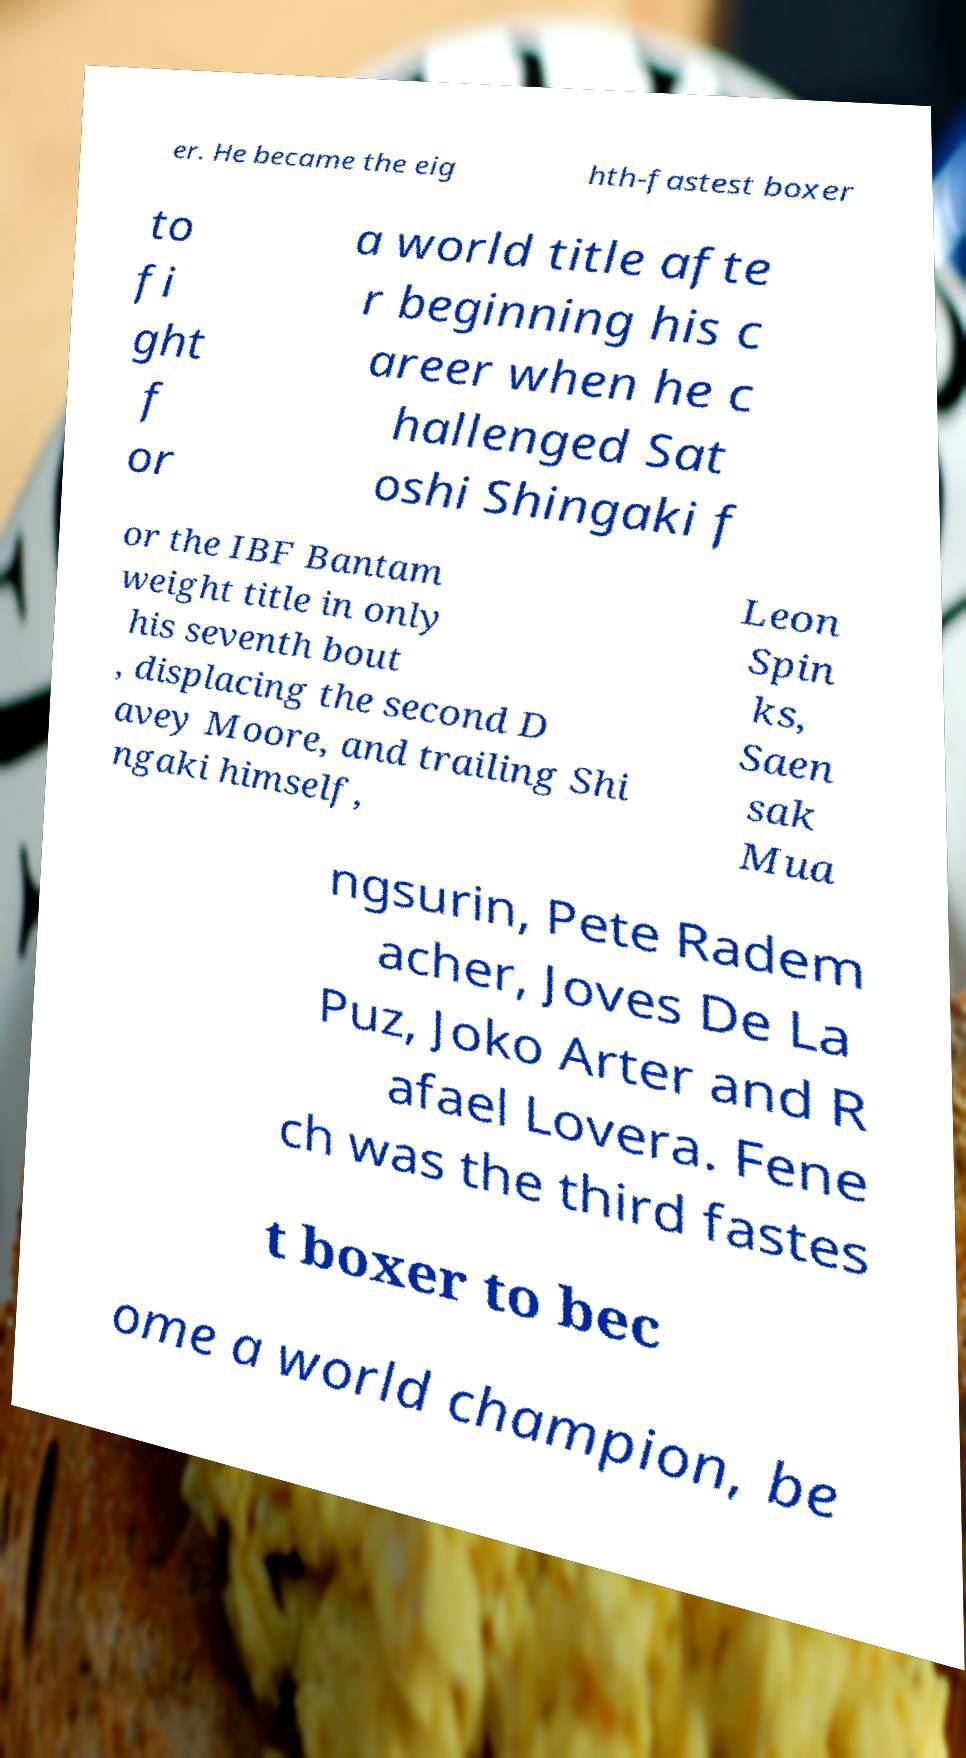There's text embedded in this image that I need extracted. Can you transcribe it verbatim? er. He became the eig hth-fastest boxer to fi ght f or a world title afte r beginning his c areer when he c hallenged Sat oshi Shingaki f or the IBF Bantam weight title in only his seventh bout , displacing the second D avey Moore, and trailing Shi ngaki himself, Leon Spin ks, Saen sak Mua ngsurin, Pete Radem acher, Joves De La Puz, Joko Arter and R afael Lovera. Fene ch was the third fastes t boxer to bec ome a world champion, be 